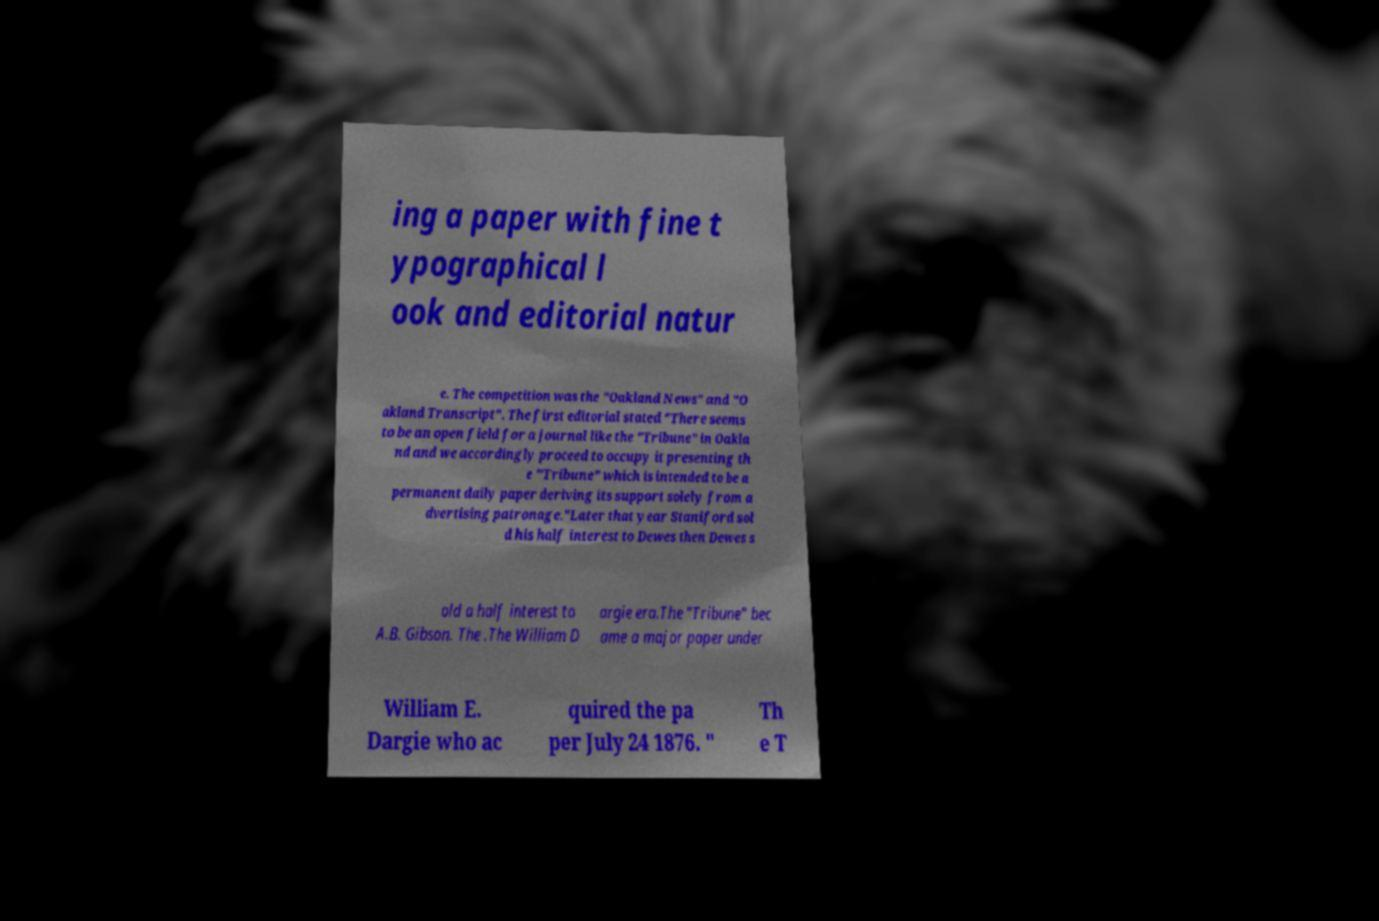Could you assist in decoding the text presented in this image and type it out clearly? ing a paper with fine t ypographical l ook and editorial natur e. The competition was the "Oakland News" and "O akland Transcript". The first editorial stated "There seems to be an open field for a journal like the "Tribune" in Oakla nd and we accordingly proceed to occupy it presenting th e "Tribune" which is intended to be a permanent daily paper deriving its support solely from a dvertising patronage."Later that year Staniford sol d his half interest to Dewes then Dewes s old a half interest to A.B. Gibson. The .The William D argie era.The "Tribune" bec ame a major paper under William E. Dargie who ac quired the pa per July 24 1876. " Th e T 